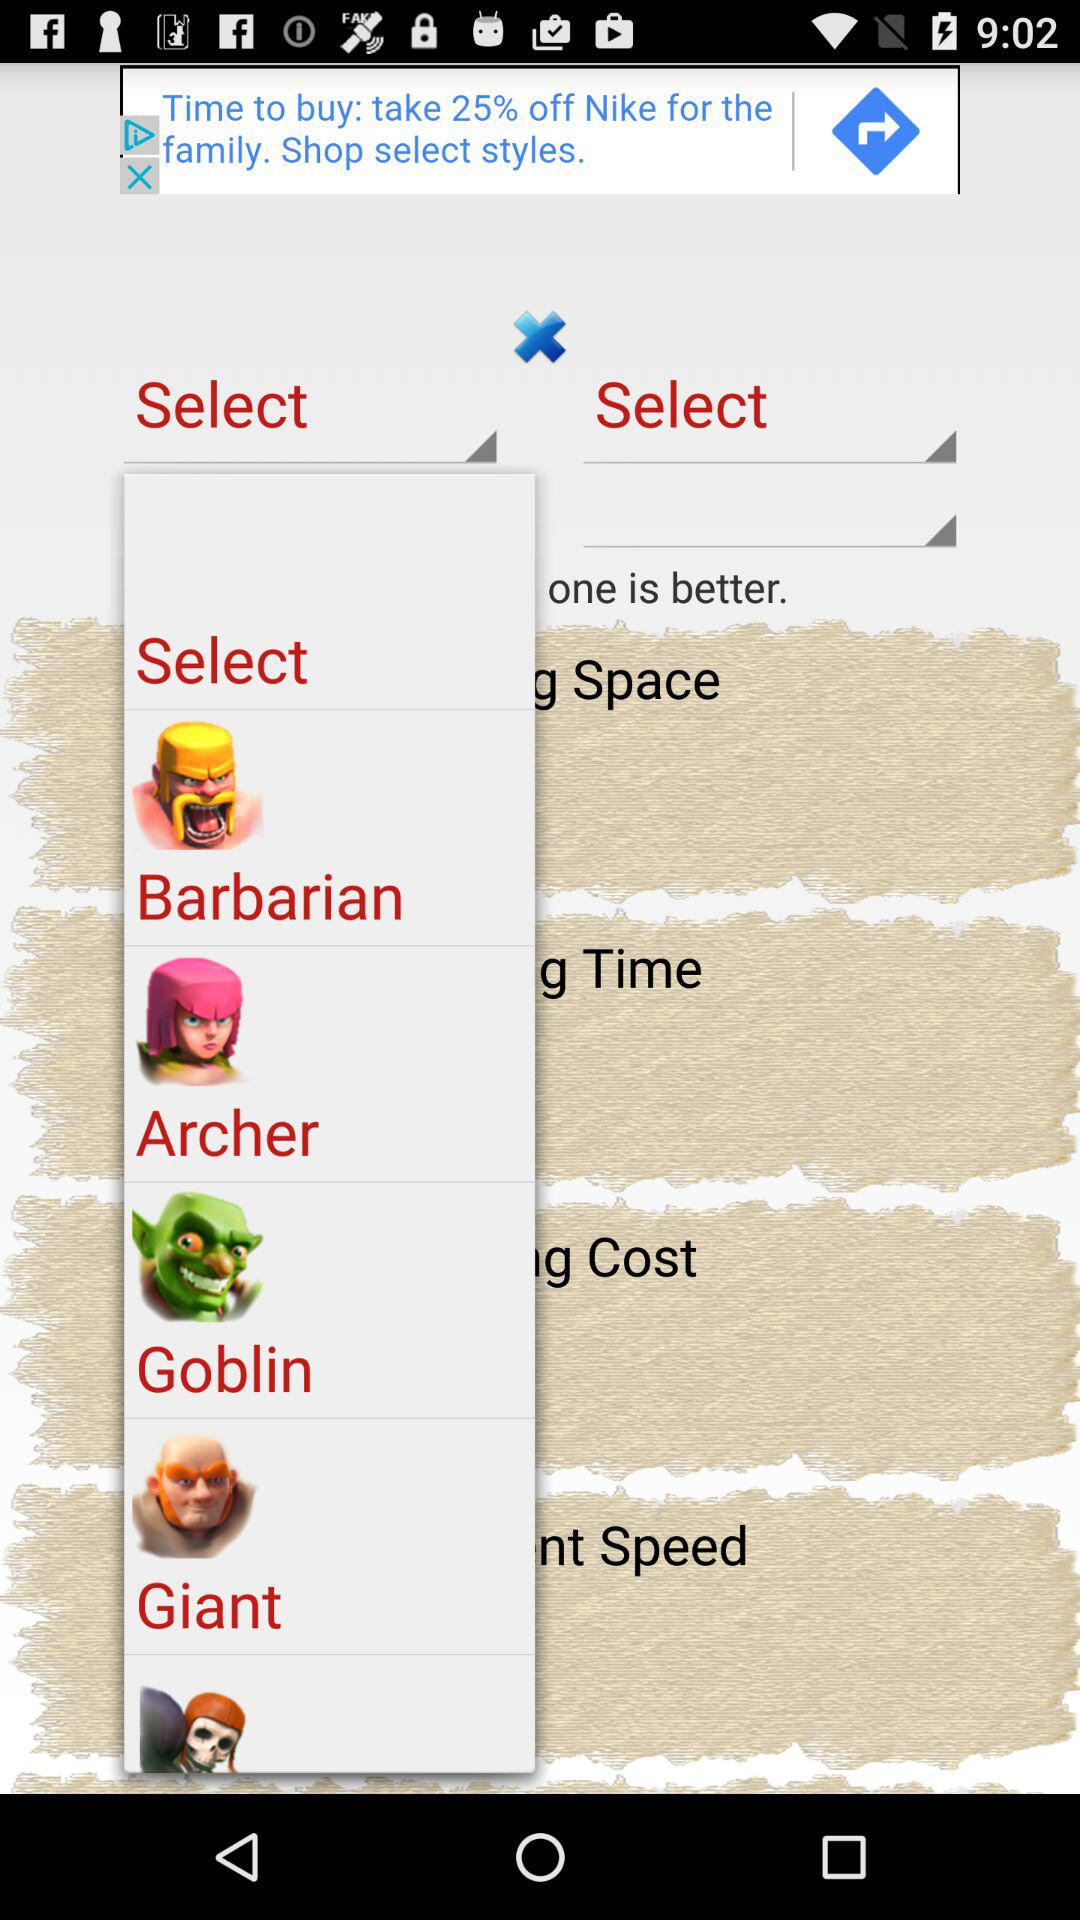Space is the virtue of which cartoon?
When the provided information is insufficient, respond with <no answer>. <no answer> 